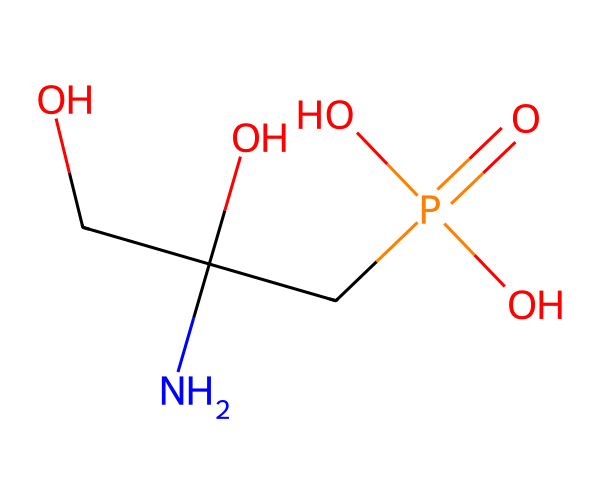What is the molecular formula of glyphosate? The SMILES representation can be translated into a molecular formula by counting the atoms of each element present. From the SMILES, there are 3 Carbon (C), 8 Hydrogen (H), 2 Nitrogen (N), 4 Oxygen (O), and 1 phosphorus (P). Thus, the molecular formula is constructed as C3H8N5O4P.
Answer: C3H8N5O4P How many oxygen atoms are in glyphosate? Observing the SMILES, we can see that there are four instances of the letter 'O', which indicates that glyphosate contains four oxygen atoms.
Answer: 4 What type of functional groups are present in glyphosate? Analyzing the structure, we can identify hydroxyl (–OH) groups and phosphate (–PO4) as functional groups present in glyphosate. The presence of nitrogen indicates it is likely to have amino groups as well.
Answer: hydroxyl and phosphate What element is bonded to the phosphorus atom in glyphosate? In the given SMILES representation, phosphorus (P) is directly bonded to four oxygen atoms. By examining the connectivity, we can confirm that phosphorus is bonded to the oxygen atoms specifically.
Answer: oxygen Which part of the glyphosate structure is responsible for its herbicidal activity? Glyphosate’s ability to inhibit the enzyme pathway necessary for plant growth is primarily due to its amine group and the phosphonate structure, which facilitates its entry and action in plants. This indicates that the nitrogen and phosphate play crucial roles in its herbicidal function.
Answer: amine and phosphate How many nitrogen atoms are present in the glyphosate structure? Looking closely at the SMILES, we can see that there are two occurrences of the letter 'N', indicating there are two nitrogen atoms in glyphosate.
Answer: 2 